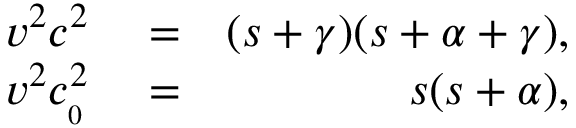<formula> <loc_0><loc_0><loc_500><loc_500>\begin{array} { r l r } { v ^ { 2 } c ^ { 2 } } & = } & { ( s + \gamma ) ( s + \alpha + \gamma ) , } \\ { v ^ { 2 } c _ { _ { 0 } } ^ { 2 } } & = } & { s ( s + \alpha ) , } \end{array}</formula> 